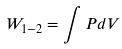<formula> <loc_0><loc_0><loc_500><loc_500>W _ { 1 - 2 } = \int P d V</formula> 